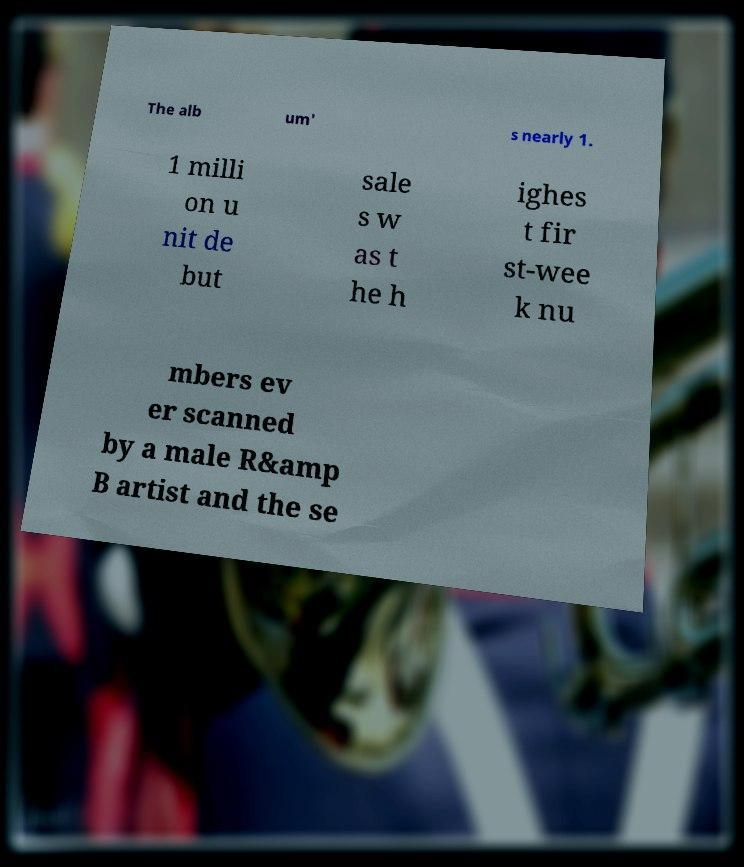Can you accurately transcribe the text from the provided image for me? The alb um' s nearly 1. 1 milli on u nit de but sale s w as t he h ighes t fir st-wee k nu mbers ev er scanned by a male R&amp B artist and the se 